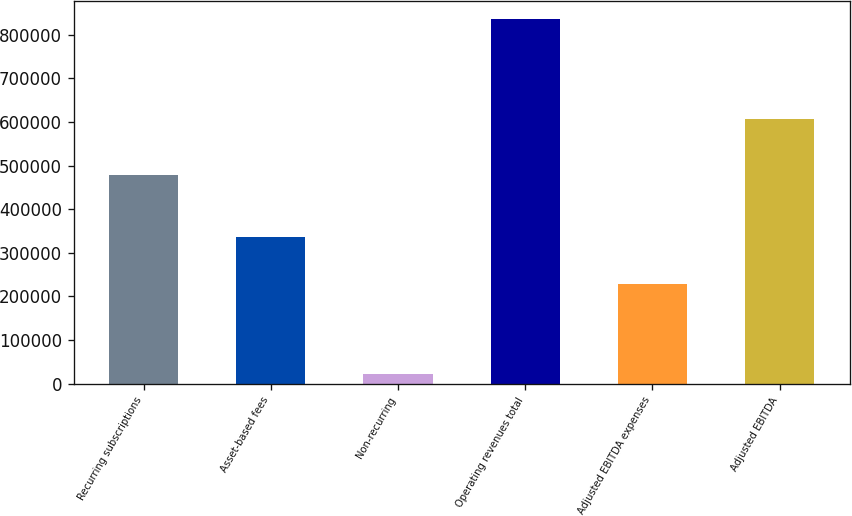<chart> <loc_0><loc_0><loc_500><loc_500><bar_chart><fcel>Recurring subscriptions<fcel>Asset-based fees<fcel>Non-recurring<fcel>Operating revenues total<fcel>Adjusted EBITDA expenses<fcel>Adjusted EBITDA<nl><fcel>477612<fcel>336565<fcel>21298<fcel>835475<fcel>227622<fcel>607853<nl></chart> 